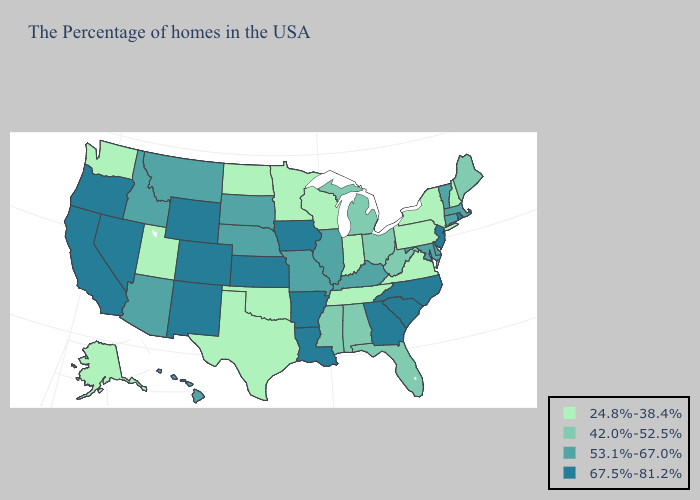What is the value of North Carolina?
Answer briefly. 67.5%-81.2%. Name the states that have a value in the range 67.5%-81.2%?
Be succinct. Rhode Island, New Jersey, North Carolina, South Carolina, Georgia, Louisiana, Arkansas, Iowa, Kansas, Wyoming, Colorado, New Mexico, Nevada, California, Oregon. Name the states that have a value in the range 53.1%-67.0%?
Short answer required. Massachusetts, Vermont, Connecticut, Delaware, Maryland, Kentucky, Illinois, Missouri, Nebraska, South Dakota, Montana, Arizona, Idaho, Hawaii. What is the lowest value in states that border Nevada?
Quick response, please. 24.8%-38.4%. Name the states that have a value in the range 24.8%-38.4%?
Write a very short answer. New Hampshire, New York, Pennsylvania, Virginia, Indiana, Tennessee, Wisconsin, Minnesota, Oklahoma, Texas, North Dakota, Utah, Washington, Alaska. What is the highest value in the USA?
Write a very short answer. 67.5%-81.2%. Among the states that border South Dakota , which have the lowest value?
Short answer required. Minnesota, North Dakota. Does Oklahoma have the lowest value in the South?
Keep it brief. Yes. Name the states that have a value in the range 67.5%-81.2%?
Quick response, please. Rhode Island, New Jersey, North Carolina, South Carolina, Georgia, Louisiana, Arkansas, Iowa, Kansas, Wyoming, Colorado, New Mexico, Nevada, California, Oregon. Which states hav the highest value in the Northeast?
Concise answer only. Rhode Island, New Jersey. Among the states that border Maine , which have the highest value?
Concise answer only. New Hampshire. Which states have the highest value in the USA?
Concise answer only. Rhode Island, New Jersey, North Carolina, South Carolina, Georgia, Louisiana, Arkansas, Iowa, Kansas, Wyoming, Colorado, New Mexico, Nevada, California, Oregon. How many symbols are there in the legend?
Quick response, please. 4. Which states have the lowest value in the USA?
Answer briefly. New Hampshire, New York, Pennsylvania, Virginia, Indiana, Tennessee, Wisconsin, Minnesota, Oklahoma, Texas, North Dakota, Utah, Washington, Alaska. 